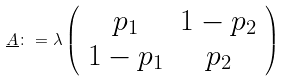Convert formula to latex. <formula><loc_0><loc_0><loc_500><loc_500>\underline { A } \colon = \lambda \left ( \begin{array} { c c } p _ { 1 } & 1 - p _ { 2 } \\ 1 - p _ { 1 } & p _ { 2 } \end{array} \right )</formula> 